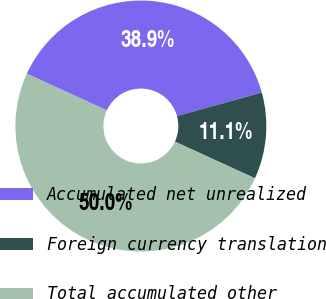Convert chart to OTSL. <chart><loc_0><loc_0><loc_500><loc_500><pie_chart><fcel>Accumulated net unrealized<fcel>Foreign currency translation<fcel>Total accumulated other<nl><fcel>38.87%<fcel>11.13%<fcel>50.0%<nl></chart> 